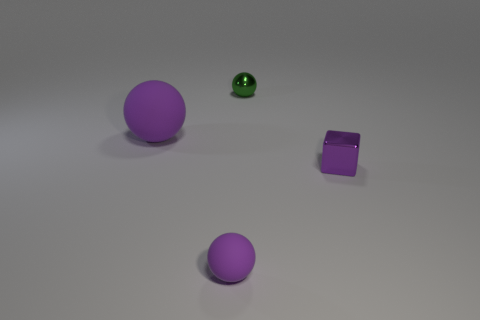Subtract all purple spheres. How many spheres are left? 1 Add 3 large red rubber objects. How many objects exist? 7 Subtract all balls. How many objects are left? 1 Subtract 0 green blocks. How many objects are left? 4 Subtract all tiny green spheres. Subtract all metallic spheres. How many objects are left? 2 Add 2 purple rubber objects. How many purple rubber objects are left? 4 Add 3 large purple spheres. How many large purple spheres exist? 4 